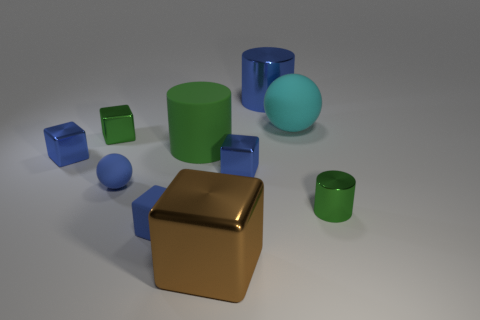What is the shape of the small rubber thing that is the same color as the matte cube?
Provide a succinct answer. Sphere. There is a matte ball that is the same color as the large metal cylinder; what is its size?
Provide a short and direct response. Small. How many other objects are there of the same shape as the big brown thing?
Give a very brief answer. 4. How many things are either small spheres or gray cubes?
Your response must be concise. 1. Is the color of the tiny rubber cube the same as the big block?
Ensure brevity in your answer.  No. Are there any other things that are the same size as the brown thing?
Provide a short and direct response. Yes. What shape is the matte thing in front of the shiny cylinder that is in front of the large cyan matte sphere?
Your answer should be compact. Cube. Are there fewer big cubes than tiny red cylinders?
Offer a terse response. No. What is the size of the metal object that is in front of the blue metallic cylinder and behind the large green rubber object?
Your answer should be compact. Small. Do the green shiny cylinder and the rubber cube have the same size?
Ensure brevity in your answer.  Yes. 